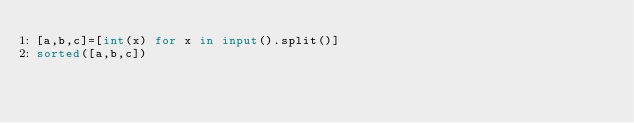<code> <loc_0><loc_0><loc_500><loc_500><_Python_>[a,b,c]=[int(x) for x in input().split()]
sorted([a,b,c])</code> 